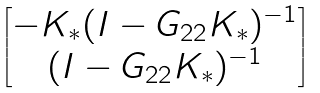Convert formula to latex. <formula><loc_0><loc_0><loc_500><loc_500>\begin{bmatrix} - K _ { * } ( I - G _ { 2 2 } K _ { * } ) ^ { - 1 } \\ ( I - G _ { 2 2 } K _ { * } ) ^ { - 1 } \end{bmatrix}</formula> 